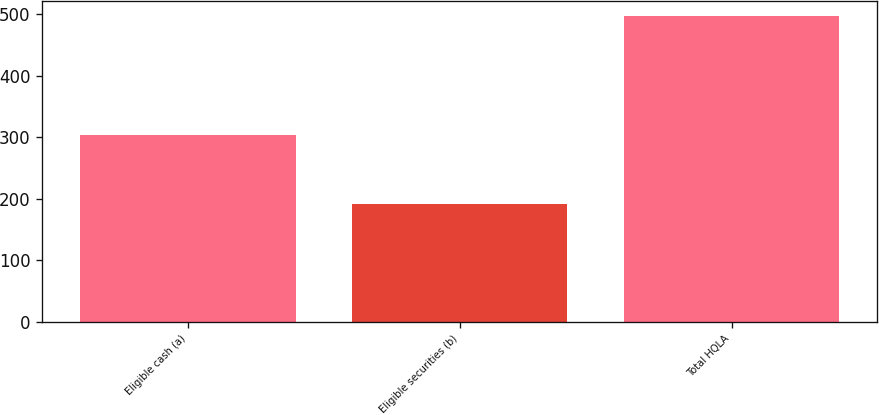<chart> <loc_0><loc_0><loc_500><loc_500><bar_chart><fcel>Eligible cash (a)<fcel>Eligible securities (b)<fcel>Total HQLA<nl><fcel>304<fcel>192<fcel>496<nl></chart> 